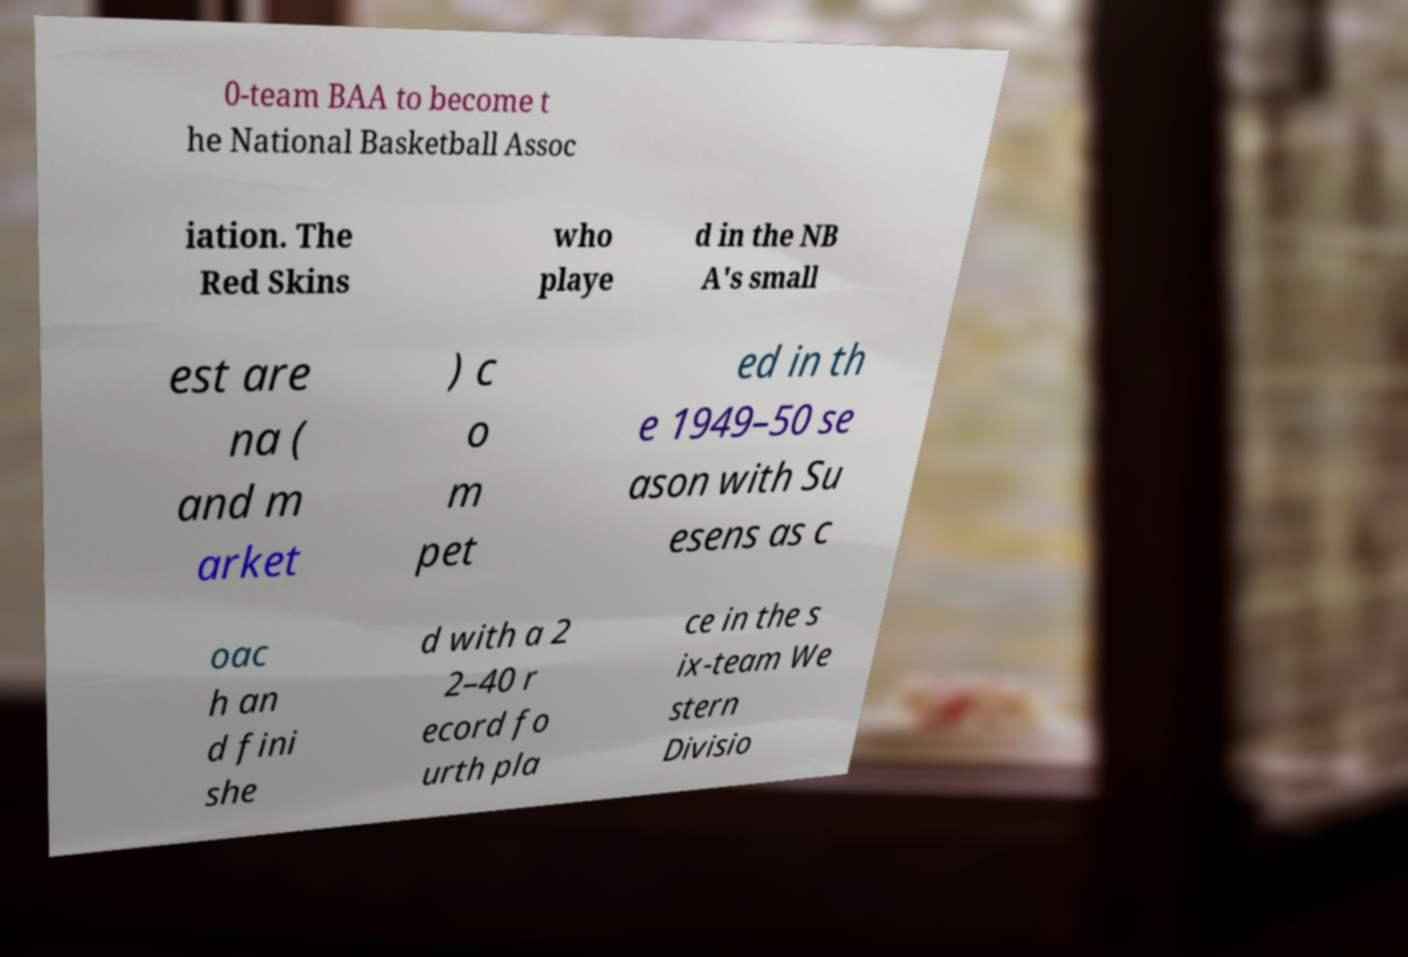Could you extract and type out the text from this image? 0-team BAA to become t he National Basketball Assoc iation. The Red Skins who playe d in the NB A's small est are na ( and m arket ) c o m pet ed in th e 1949–50 se ason with Su esens as c oac h an d fini she d with a 2 2–40 r ecord fo urth pla ce in the s ix-team We stern Divisio 